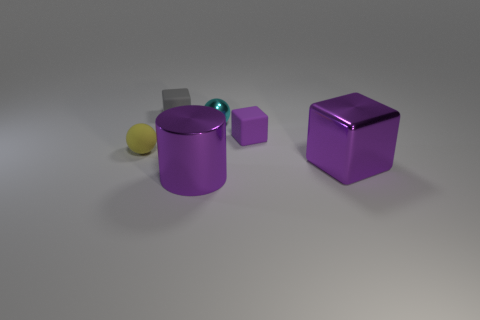Add 1 tiny green objects. How many objects exist? 7 Subtract all spheres. How many objects are left? 4 Add 4 metal balls. How many metal balls exist? 5 Subtract 0 blue spheres. How many objects are left? 6 Subtract all small brown rubber spheres. Subtract all big blocks. How many objects are left? 5 Add 1 matte cubes. How many matte cubes are left? 3 